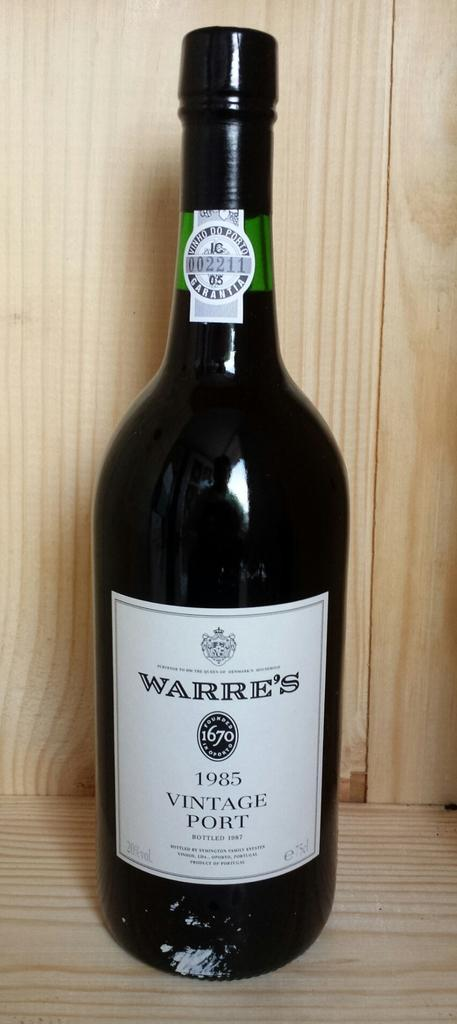<image>
Describe the image concisely. The brand of wine here is Warre's and is of 1985 vintage 